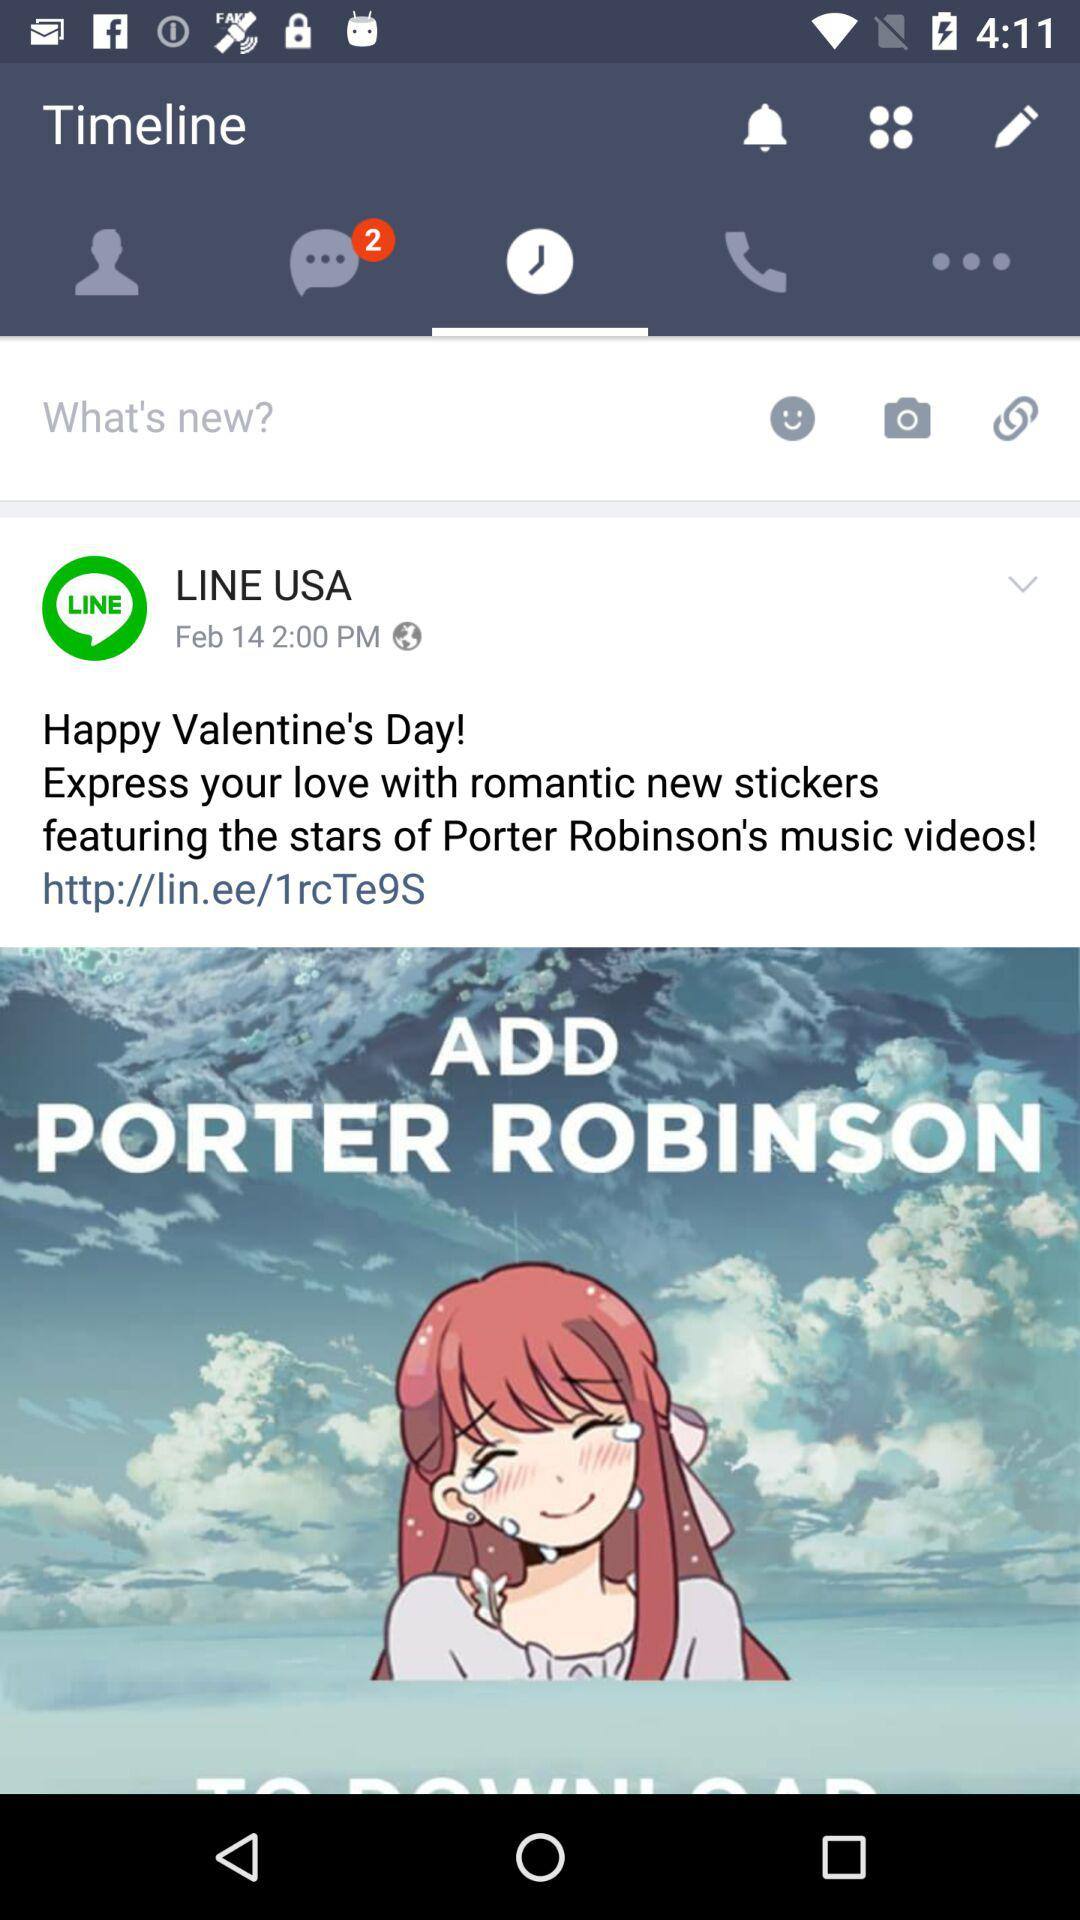How many unread notifications are there? There are 2 unread notifications. 